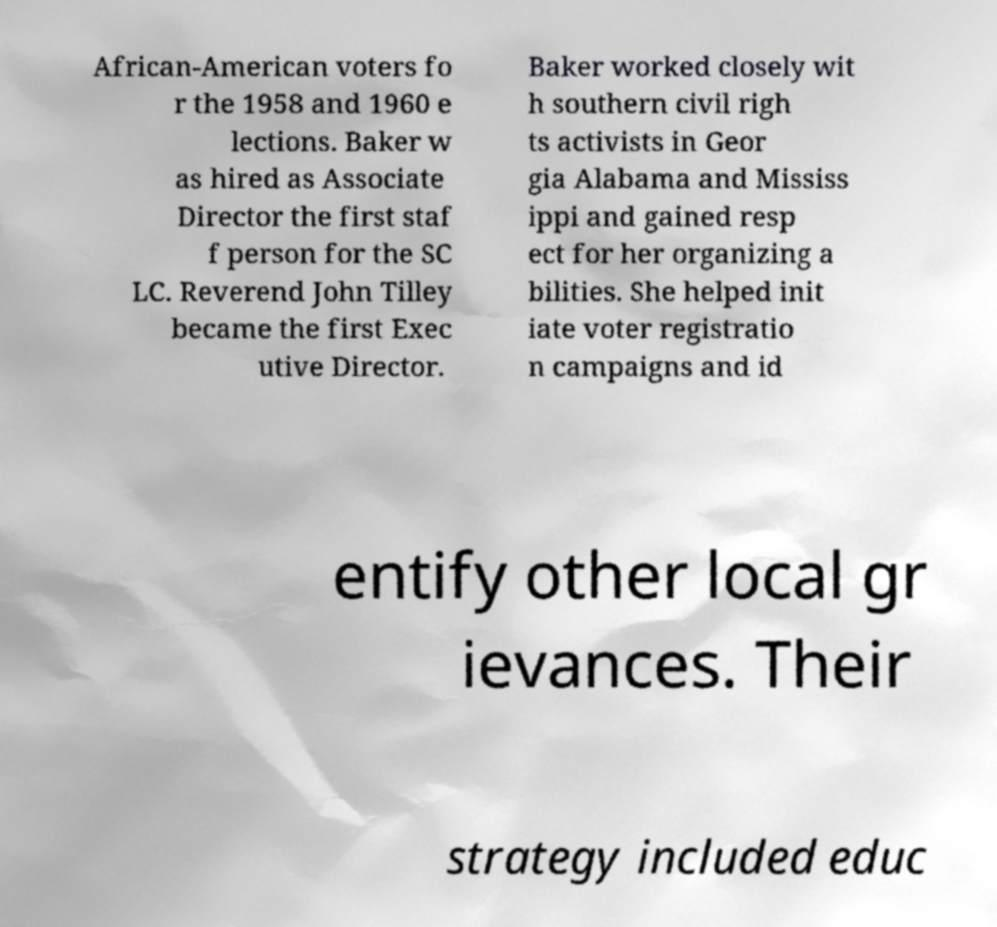I need the written content from this picture converted into text. Can you do that? African-American voters fo r the 1958 and 1960 e lections. Baker w as hired as Associate Director the first staf f person for the SC LC. Reverend John Tilley became the first Exec utive Director. Baker worked closely wit h southern civil righ ts activists in Geor gia Alabama and Mississ ippi and gained resp ect for her organizing a bilities. She helped init iate voter registratio n campaigns and id entify other local gr ievances. Their strategy included educ 